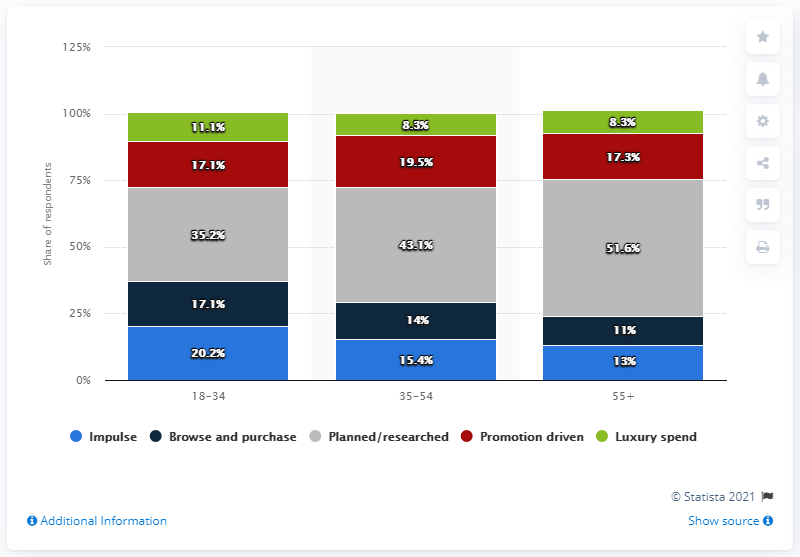Indicate a few pertinent items in this graphic. According to the data, 35.2% of shoppers in the same age group claim that their purchase decisions are planned and researched. According to a recent survey, approximately 20.2% of 18 to 34 year olds are driven to make impulsive decisions. 